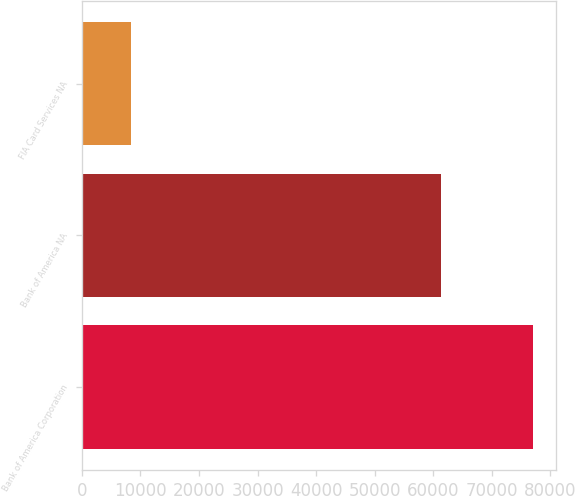Convert chart. <chart><loc_0><loc_0><loc_500><loc_500><bar_chart><fcel>Bank of America Corporation<fcel>Bank of America NA<fcel>FIA Card Services NA<nl><fcel>77068<fcel>61245<fcel>8393<nl></chart> 